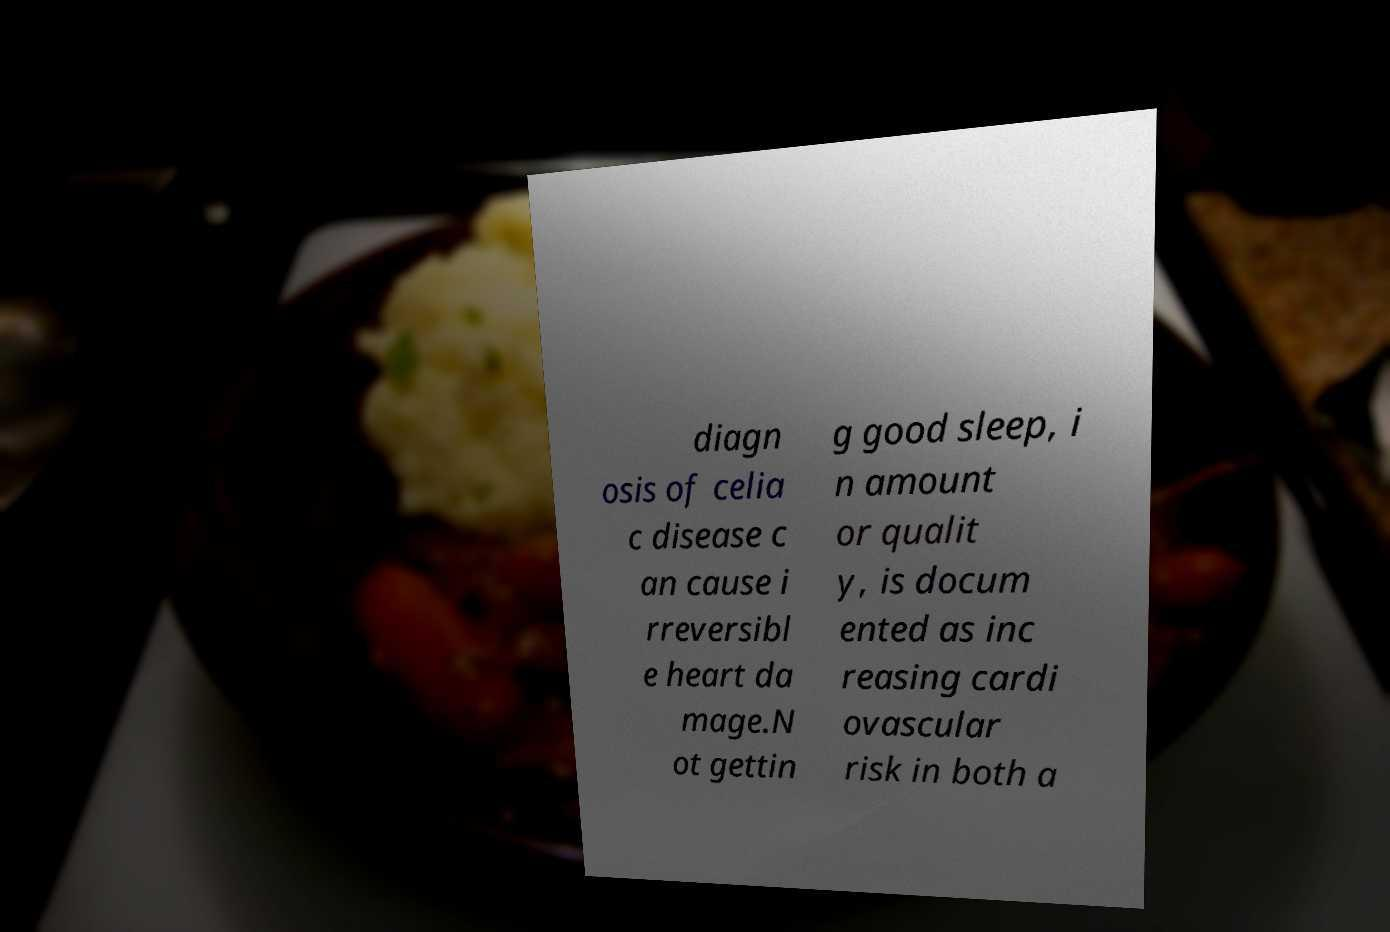I need the written content from this picture converted into text. Can you do that? diagn osis of celia c disease c an cause i rreversibl e heart da mage.N ot gettin g good sleep, i n amount or qualit y, is docum ented as inc reasing cardi ovascular risk in both a 